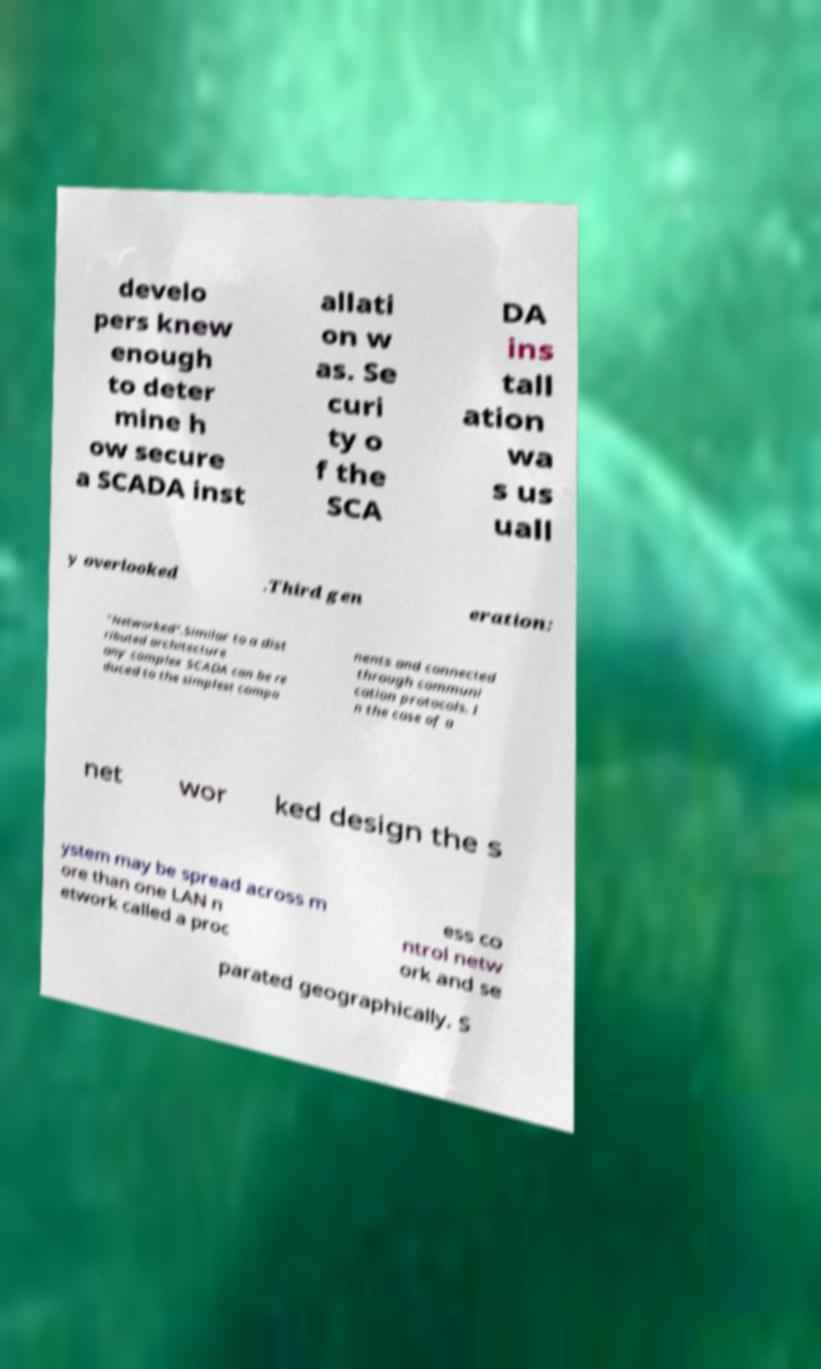There's text embedded in this image that I need extracted. Can you transcribe it verbatim? develo pers knew enough to deter mine h ow secure a SCADA inst allati on w as. Se curi ty o f the SCA DA ins tall ation wa s us uall y overlooked .Third gen eration: "Networked".Similar to a dist ributed architecture any complex SCADA can be re duced to the simplest compo nents and connected through communi cation protocols. I n the case of a net wor ked design the s ystem may be spread across m ore than one LAN n etwork called a proc ess co ntrol netw ork and se parated geographically. S 